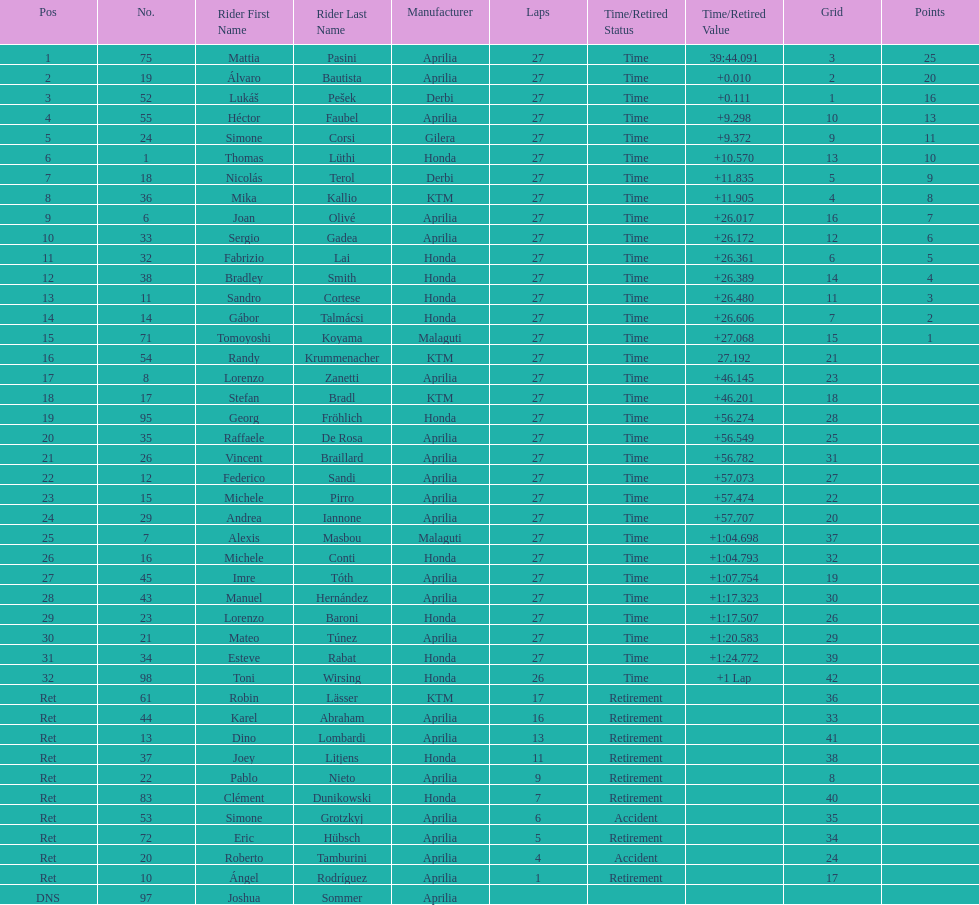Give me the full table as a dictionary. {'header': ['Pos', 'No.', 'Rider First Name', 'Rider Last Name', 'Manufacturer', 'Laps', 'Time/Retired Status', 'Time/Retired Value', 'Grid', 'Points'], 'rows': [['1', '75', 'Mattia', 'Pasini', 'Aprilia', '27', 'Time', '39:44.091', '3', '25'], ['2', '19', 'Álvaro', 'Bautista', 'Aprilia', '27', 'Time', '+0.010', '2', '20'], ['3', '52', 'Lukáš', 'Pešek', 'Derbi', '27', 'Time', '+0.111', '1', '16'], ['4', '55', 'Héctor', 'Faubel', 'Aprilia', '27', 'Time', '+9.298', '10', '13'], ['5', '24', 'Simone', 'Corsi', 'Gilera', '27', 'Time', '+9.372', '9', '11'], ['6', '1', 'Thomas', 'Lüthi', 'Honda', '27', 'Time', '+10.570', '13', '10'], ['7', '18', 'Nicolás', 'Terol', 'Derbi', '27', 'Time', '+11.835', '5', '9'], ['8', '36', 'Mika', 'Kallio', 'KTM', '27', 'Time', '+11.905', '4', '8'], ['9', '6', 'Joan', 'Olivé', 'Aprilia', '27', 'Time', '+26.017', '16', '7'], ['10', '33', 'Sergio', 'Gadea', 'Aprilia', '27', 'Time', '+26.172', '12', '6'], ['11', '32', 'Fabrizio', 'Lai', 'Honda', '27', 'Time', '+26.361', '6', '5'], ['12', '38', 'Bradley', 'Smith', 'Honda', '27', 'Time', '+26.389', '14', '4'], ['13', '11', 'Sandro', 'Cortese', 'Honda', '27', 'Time', '+26.480', '11', '3'], ['14', '14', 'Gábor', 'Talmácsi', 'Honda', '27', 'Time', '+26.606', '7', '2'], ['15', '71', 'Tomoyoshi', 'Koyama', 'Malaguti', '27', 'Time', '+27.068', '15', '1'], ['16', '54', 'Randy', 'Krummenacher', 'KTM', '27', 'Time', '27.192', '21', ''], ['17', '8', 'Lorenzo', 'Zanetti', 'Aprilia', '27', 'Time', '+46.145', '23', ''], ['18', '17', 'Stefan', 'Bradl', 'KTM', '27', 'Time', '+46.201', '18', ''], ['19', '95', 'Georg', 'Fröhlich', 'Honda', '27', 'Time', '+56.274', '28', ''], ['20', '35', 'Raffaele', 'De Rosa', 'Aprilia', '27', 'Time', '+56.549', '25', ''], ['21', '26', 'Vincent', 'Braillard', 'Aprilia', '27', 'Time', '+56.782', '31', ''], ['22', '12', 'Federico', 'Sandi', 'Aprilia', '27', 'Time', '+57.073', '27', ''], ['23', '15', 'Michele', 'Pirro', 'Aprilia', '27', 'Time', '+57.474', '22', ''], ['24', '29', 'Andrea', 'Iannone', 'Aprilia', '27', 'Time', '+57.707', '20', ''], ['25', '7', 'Alexis', 'Masbou', 'Malaguti', '27', 'Time', '+1:04.698', '37', ''], ['26', '16', 'Michele', 'Conti', 'Honda', '27', 'Time', '+1:04.793', '32', ''], ['27', '45', 'Imre', 'Tóth', 'Aprilia', '27', 'Time', '+1:07.754', '19', ''], ['28', '43', 'Manuel', 'Hernández', 'Aprilia', '27', 'Time', '+1:17.323', '30', ''], ['29', '23', 'Lorenzo', 'Baroni', 'Honda', '27', 'Time', '+1:17.507', '26', ''], ['30', '21', 'Mateo', 'Túnez', 'Aprilia', '27', 'Time', '+1:20.583', '29', ''], ['31', '34', 'Esteve', 'Rabat', 'Honda', '27', 'Time', '+1:24.772', '39', ''], ['32', '98', 'Toni', 'Wirsing', 'Honda', '26', 'Time', '+1 Lap', '42', ''], ['Ret', '61', 'Robin', 'Lässer', 'KTM', '17', 'Retirement', '', '36', ''], ['Ret', '44', 'Karel', 'Abraham', 'Aprilia', '16', 'Retirement', '', '33', ''], ['Ret', '13', 'Dino', 'Lombardi', 'Aprilia', '13', 'Retirement', '', '41', ''], ['Ret', '37', 'Joey', 'Litjens', 'Honda', '11', 'Retirement', '', '38', ''], ['Ret', '22', 'Pablo', 'Nieto', 'Aprilia', '9', 'Retirement', '', '8', ''], ['Ret', '83', 'Clément', 'Dunikowski', 'Honda', '7', 'Retirement', '', '40', ''], ['Ret', '53', 'Simone', 'Grotzkyj', 'Aprilia', '6', 'Accident', '', '35', ''], ['Ret', '72', 'Eric', 'Hübsch', 'Aprilia', '5', 'Retirement', '', '34', ''], ['Ret', '20', 'Roberto', 'Tamburini', 'Aprilia', '4', 'Accident', '', '24', ''], ['Ret', '10', 'Ángel', 'Rodríguez', 'Aprilia', '1', 'Retirement', '', '17', ''], ['DNS', '97', 'Joshua', 'Sommer', 'Aprilia', '', '', '', '', '']]} Name a racer that had at least 20 points. Mattia Pasini. 